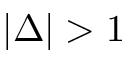<formula> <loc_0><loc_0><loc_500><loc_500>| \Delta | > 1</formula> 